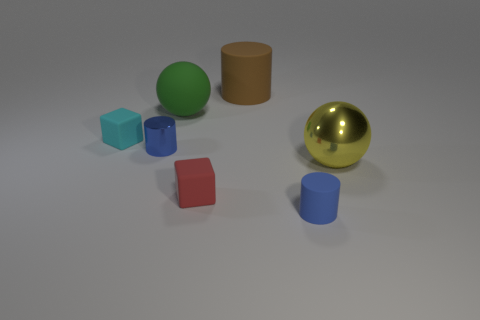Add 2 big brown metal balls. How many objects exist? 9 Subtract all cylinders. How many objects are left? 4 Subtract 0 gray spheres. How many objects are left? 7 Subtract all large brown cylinders. Subtract all cyan matte cubes. How many objects are left? 5 Add 2 metal spheres. How many metal spheres are left? 3 Add 7 rubber cylinders. How many rubber cylinders exist? 9 